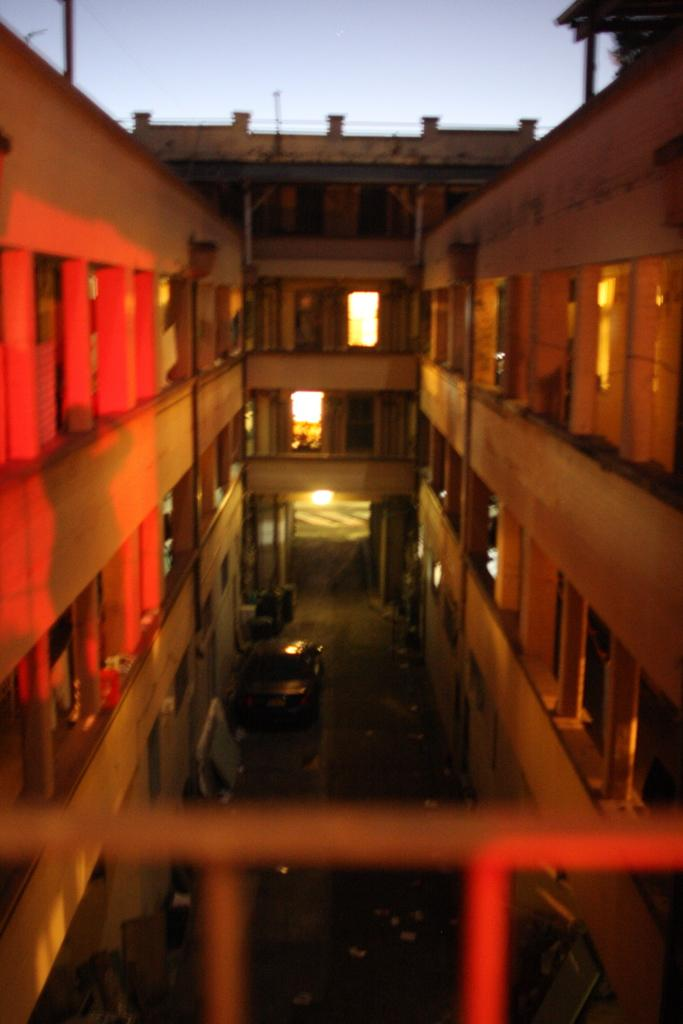What type of structure is present in the image? There is a building in the image. What else can be seen on the ground in the image? A car is parked on the road in the image. What is visible in the background of the image? The sky is visible in the background of the image. Can you see any plants growing in the car in the image? There are no plants visible inside the car in the image. How many attempts does the building make to breathe in the image? Buildings do not breathe, so this question cannot be answered. 